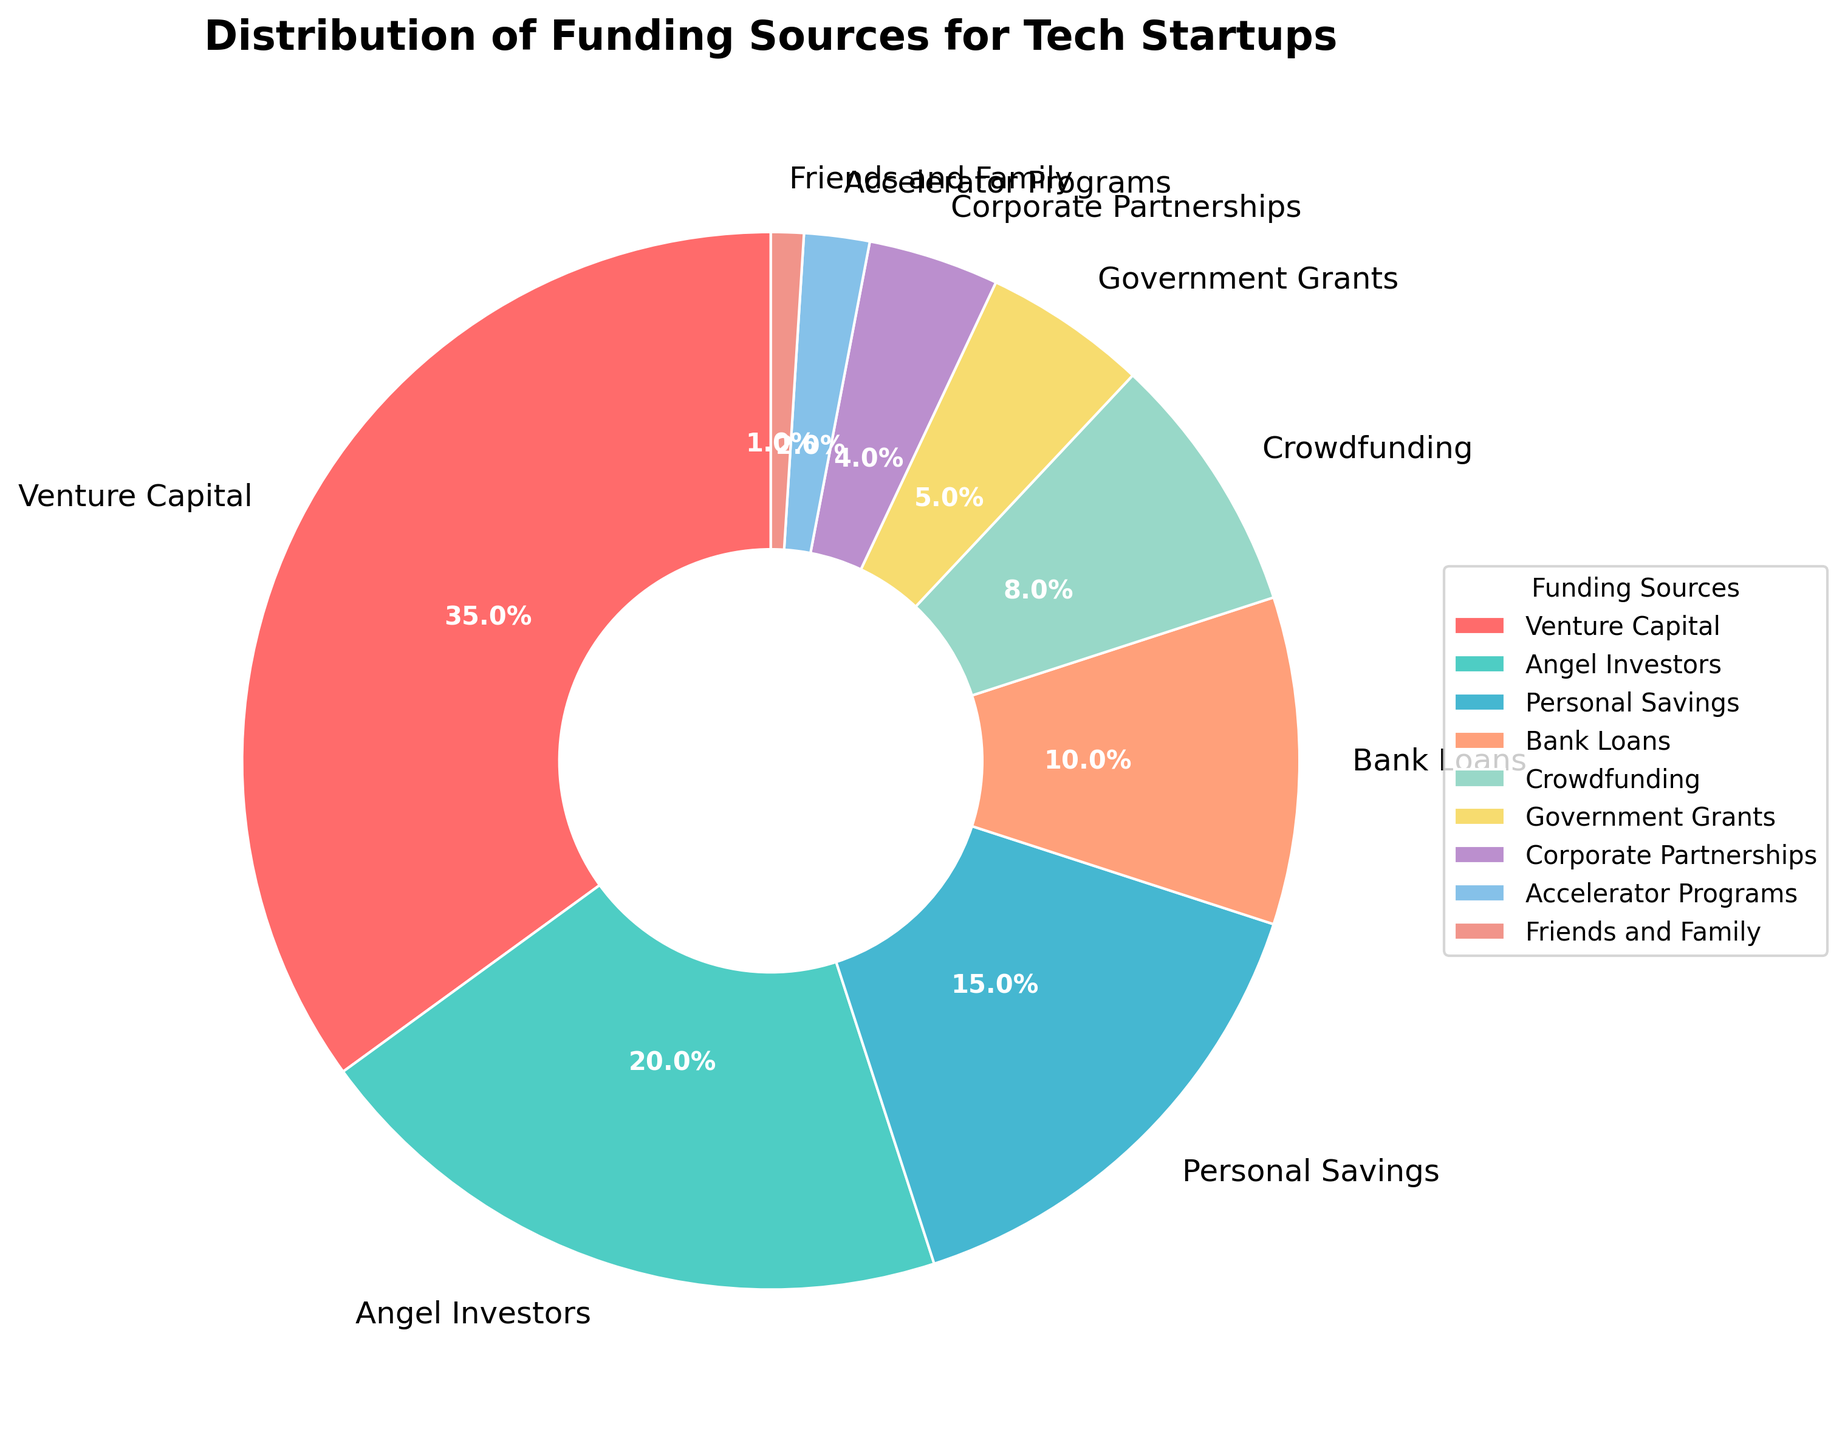What is the total percentage of startup funding from bank loans and government grants? The figure shows the percentage of startup funding sources. Adding the percentages for Bank Loans (10%) and Government Grants (5%) gives us the total percentage.
Answer: 15% Which funding source has a higher percentage: Crowdfunding or Accelerator Programs? By comparing the percentages in the figure, Crowdfunding has 8% and Accelerator Programs have 2%. 8% is greater than 2%.
Answer: Crowdfunding What is the difference in percentage between Venture Capital and Personal Savings? The percentage for Venture Capital is 35%, and for Personal Savings, it is 15%. Subtracting these gives the difference: 35% - 15%.
Answer: 20% Which funding source has the smallest percentage? The figure shows that Friends and Family has the smallest percentage at 1%.
Answer: Friends and Family What is the combined total percentage of funding sources that are less than 10%? The funding sources with percentages less than 10% are Bank Loans (10%), Crowdfunding (8%), Government Grants (5%), Corporate Partnerships (4%), Accelerator Programs (2%), and Friends and Family (1%). Summing these percentages: 10% + 8% + 5% + 4% + 2% + 1%.
Answer: 30% Which segment is represented by the red color? The figure shows that Venture Capital is represented by the red segment.
Answer: Venture Capital How many funding sources have a percentage greater than 5%? By scanning through the figure, the funding sources greater than 5% are Venture Capital (35%), Angel Investors (20%), Personal Savings (15%), and Crowdfunding (8%). There are 4 such funding sources.
Answer: 4 What is the average percentage of funding from Angel Investors and Corporate Partnerships? The percentage for Angel Investors is 20%, and for Corporate Partnerships, it is 4%. The sum is 24%, and the average is 24% / 2.
Answer: 12% Is the percentage of funding from Government Grants more or less than Personal Savings? Government Grants have 5%, whereas Personal Savings have 15%. Since 5% is less than 15%, Government Grants is less.
Answer: Less What is the percentage of funding from Personal Savings relative to the total from Venture Capital, Angel Investors, and Bank Loans? The percentages for Venture Capital (35%), Angel Investors (20%), and Bank Loans (10%) add up to 65%. The percentage from Personal Savings is 15%. To find the relative percentage: (15% / 65%) * 100.
Answer: 23.1% 